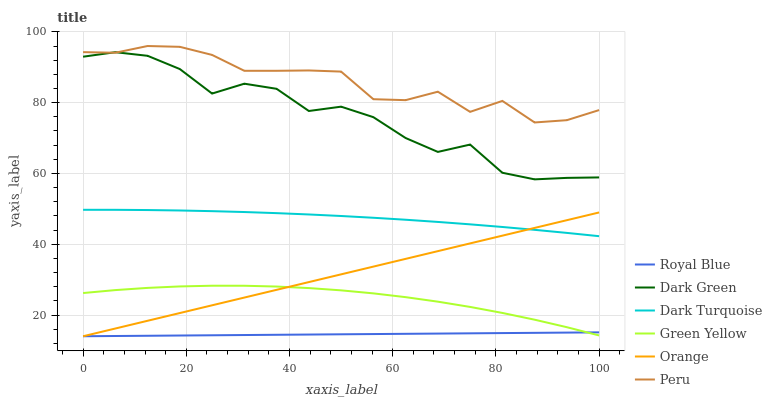Does Peru have the minimum area under the curve?
Answer yes or no. No. Does Royal Blue have the maximum area under the curve?
Answer yes or no. No. Is Peru the smoothest?
Answer yes or no. No. Is Peru the roughest?
Answer yes or no. No. Does Peru have the lowest value?
Answer yes or no. No. Does Royal Blue have the highest value?
Answer yes or no. No. Is Dark Turquoise less than Dark Green?
Answer yes or no. Yes. Is Dark Green greater than Orange?
Answer yes or no. Yes. Does Dark Turquoise intersect Dark Green?
Answer yes or no. No. 